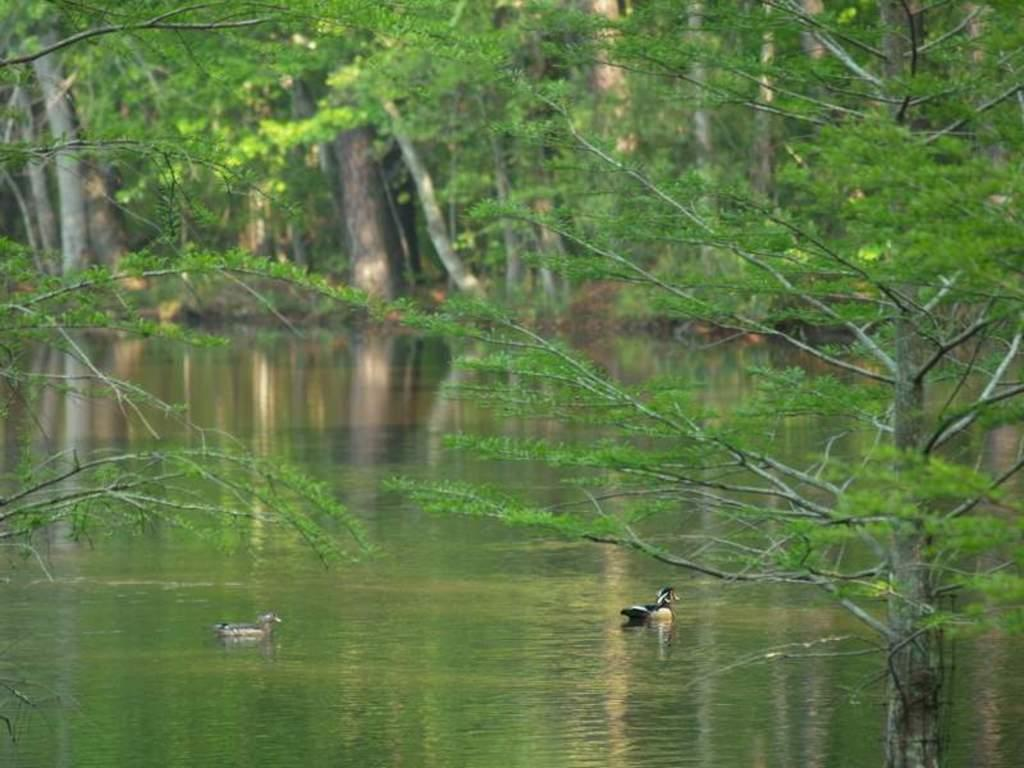What is located in the foreground of the image? There are trees in the foreground of the image. What is in the middle of the image? There is a surface of water in the middle of the image. What animals can be seen in the water? There are ducks in the water. What can be seen in the background of the image? There are trees visible in the background of the image. What type of pipe is visible in the image? There is no pipe present in the image. How does the rainstorm affect the ducks in the image? There is no rainstorm present in the image; it is a clear day with ducks in the water. 